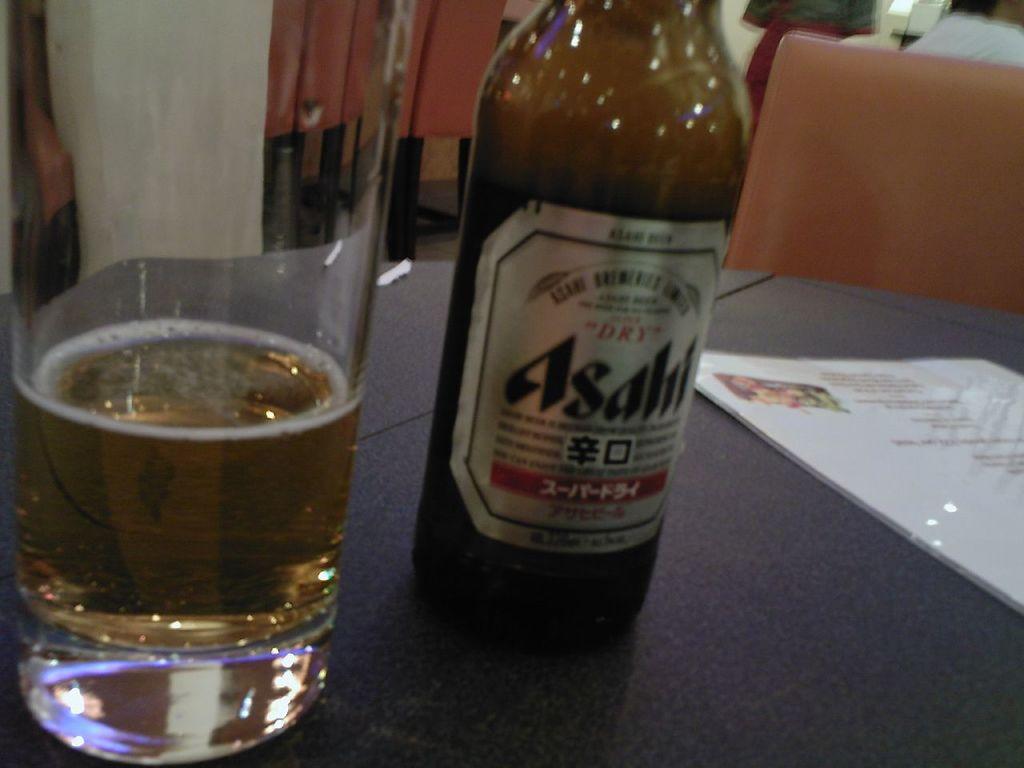Does it mention if the beer is wet or dry on the bottle?
Give a very brief answer. Dry. 